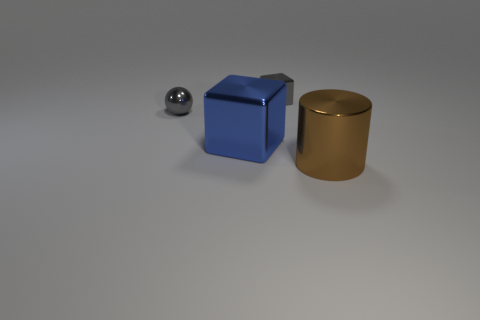Add 1 cubes. How many objects exist? 5 Subtract all cylinders. How many objects are left? 3 Add 4 small gray blocks. How many small gray blocks are left? 5 Add 3 metal balls. How many metal balls exist? 4 Subtract 0 red cylinders. How many objects are left? 4 Subtract all brown metallic blocks. Subtract all brown cylinders. How many objects are left? 3 